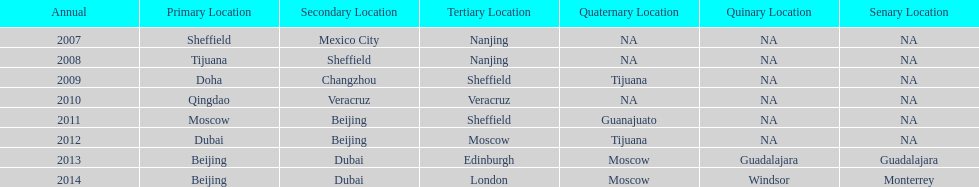What was the last year where tijuana was a venue? 2012. 